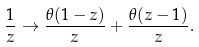<formula> <loc_0><loc_0><loc_500><loc_500>\frac { 1 } { z } \rightarrow \frac { \theta ( 1 - z ) } { z } + \frac { \theta ( z - 1 ) } { z } .</formula> 